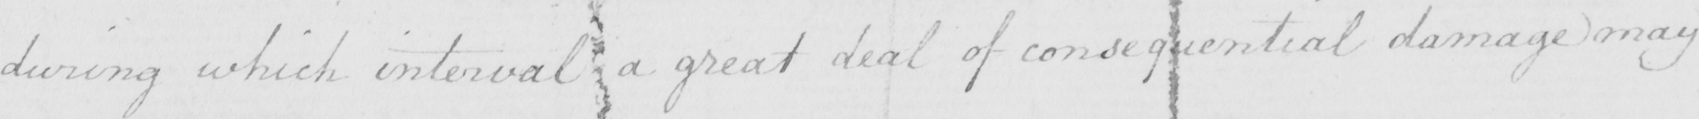Can you read and transcribe this handwriting? during which interval a great deal of consequential damage may 